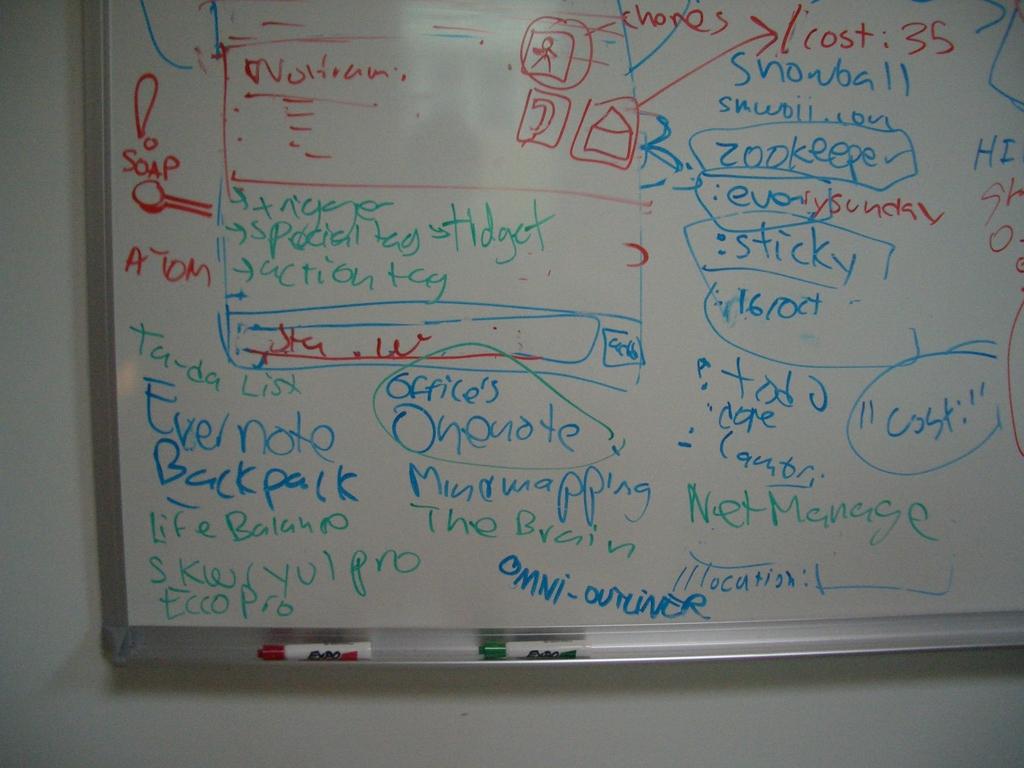What is the word written in red under the exclamation mark on the left?
Make the answer very short. Soap. 